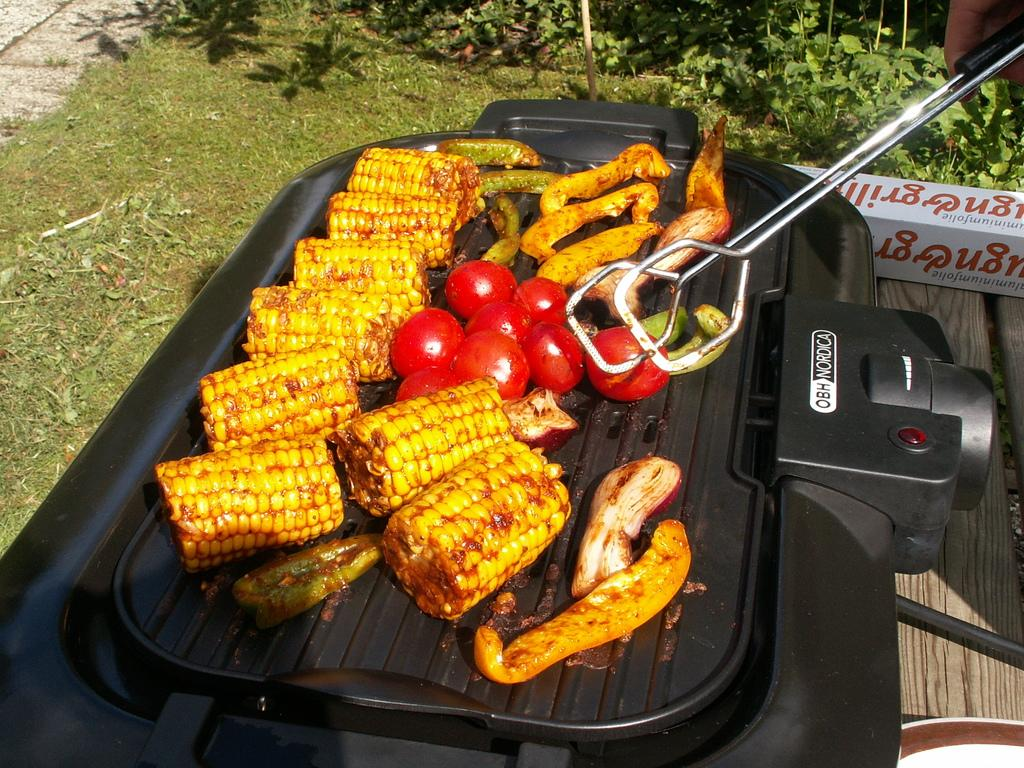<image>
Create a compact narrative representing the image presented. an obh-mordica grill in use to grill vegetables and some kind of meat 